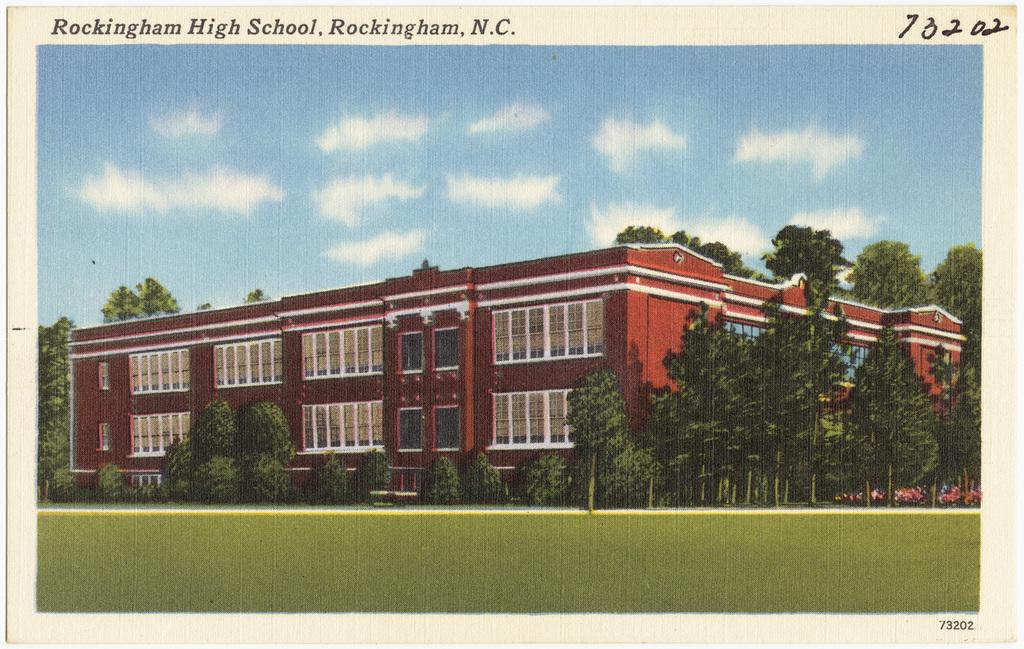What is the main subject of the image? The image contains a picture. What types of structures can be seen in the picture? There are buildings in the picture. What type of natural elements are present in the picture? There are trees in the picture. What part of the natural environment is visible in the picture? The ground is visible in the picture. What man-made feature can be seen in the picture? There is a road in the picture. What part of the sky is visible in the picture? The sky is visible in the picture. What atmospheric elements can be seen in the sky? Clouds are present in the sky. What type of pipe is visible in the picture? There is no pipe present in the image. What is the current state of the expansion project in the picture? There is no mention of an expansion project in the image. 